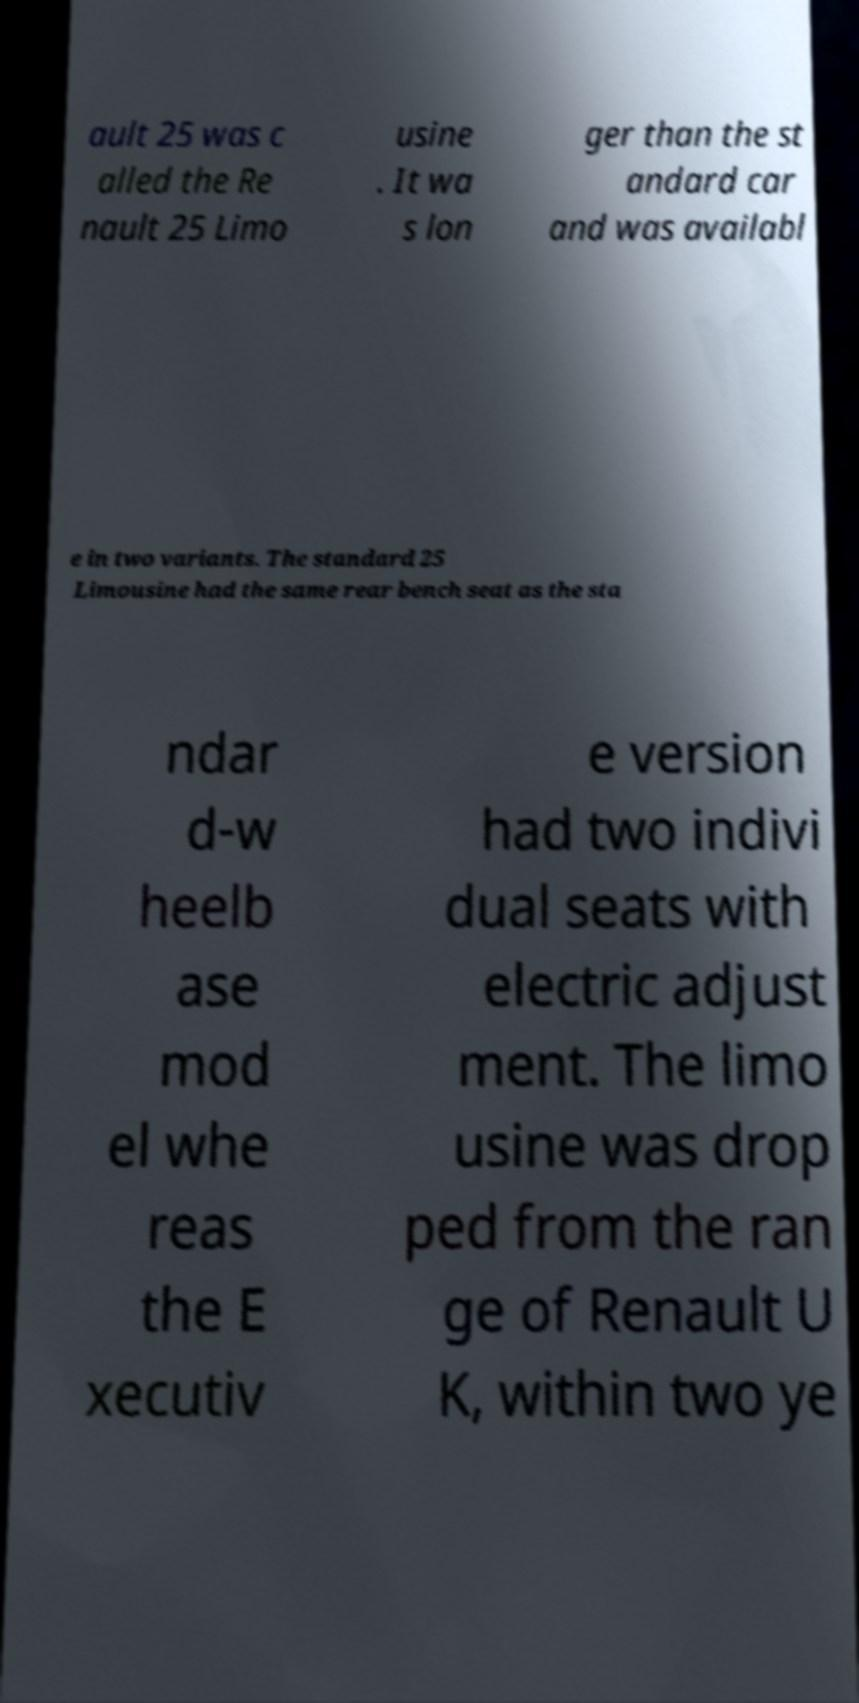Can you accurately transcribe the text from the provided image for me? ault 25 was c alled the Re nault 25 Limo usine . It wa s lon ger than the st andard car and was availabl e in two variants. The standard 25 Limousine had the same rear bench seat as the sta ndar d-w heelb ase mod el whe reas the E xecutiv e version had two indivi dual seats with electric adjust ment. The limo usine was drop ped from the ran ge of Renault U K, within two ye 